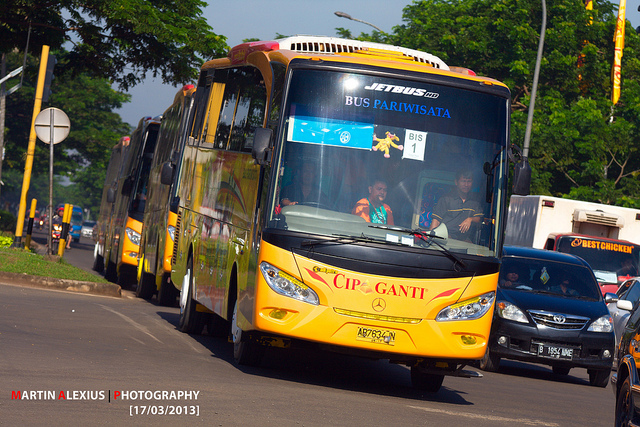Can you imagine a futuristic scenario involving this bus? In a futuristic scenario, these buses could be part of a smart city ecosystem. They would be equipped with autonomous driving capabilities, powered by renewable energy sources like solar or hydrogen fuel cells. The buses’ windows could be interactive screens, providing real-time augmented reality tours that communicate the history and special facts about the locations they pass by. Passengers could enjoy personalized entertainment options through advanced holographic displays right from their seats. The buses would be continuously connected to a central network, optimizing routes to avoid traffic and ensuring a smooth journey for everyone on board. 